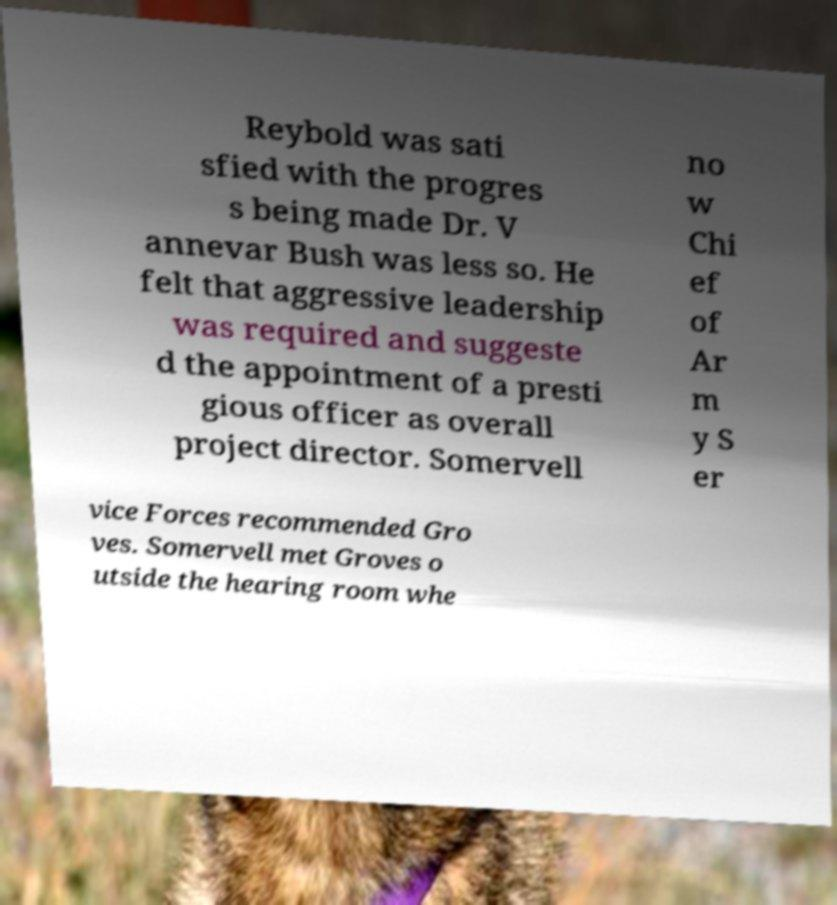Please read and relay the text visible in this image. What does it say? Reybold was sati sfied with the progres s being made Dr. V annevar Bush was less so. He felt that aggressive leadership was required and suggeste d the appointment of a presti gious officer as overall project director. Somervell no w Chi ef of Ar m y S er vice Forces recommended Gro ves. Somervell met Groves o utside the hearing room whe 